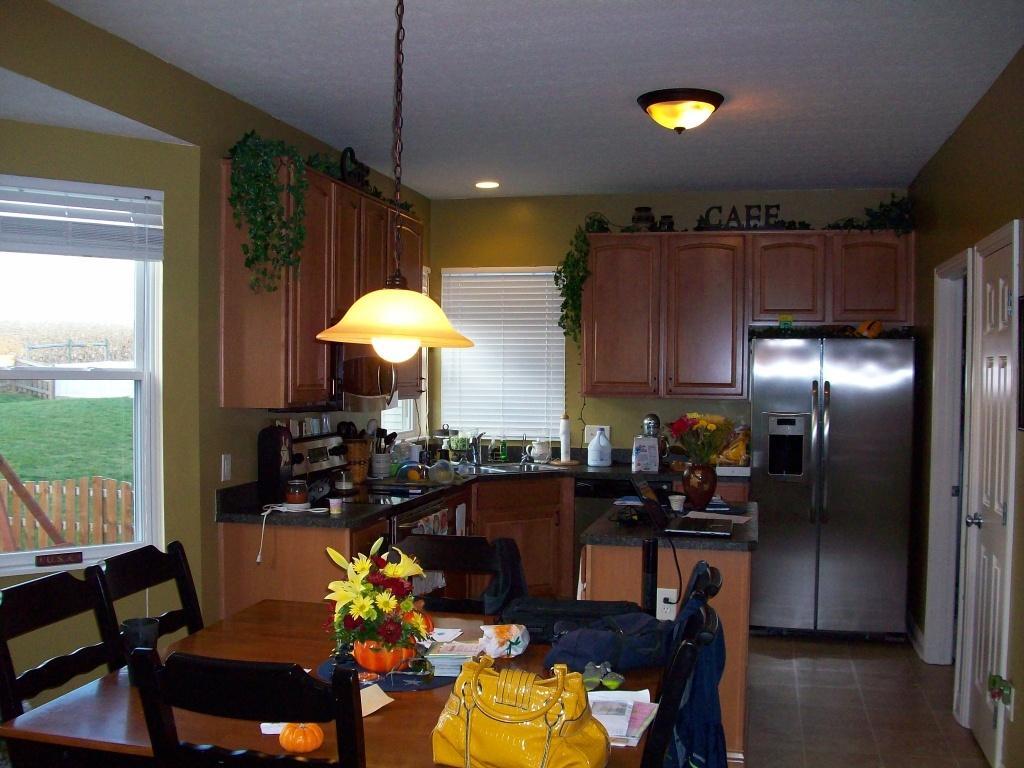How would you summarize this image in a sentence or two? This picture is taken inside a kitchen, in this image there is a table, on that table there is a bag, flower vase, and few objects around the table there are chairs, in the background there is a kitchen cabinet on that there are few objects, at the top there are cupboards, ceiling and lights and there are walls near the wall there is a fridge. 